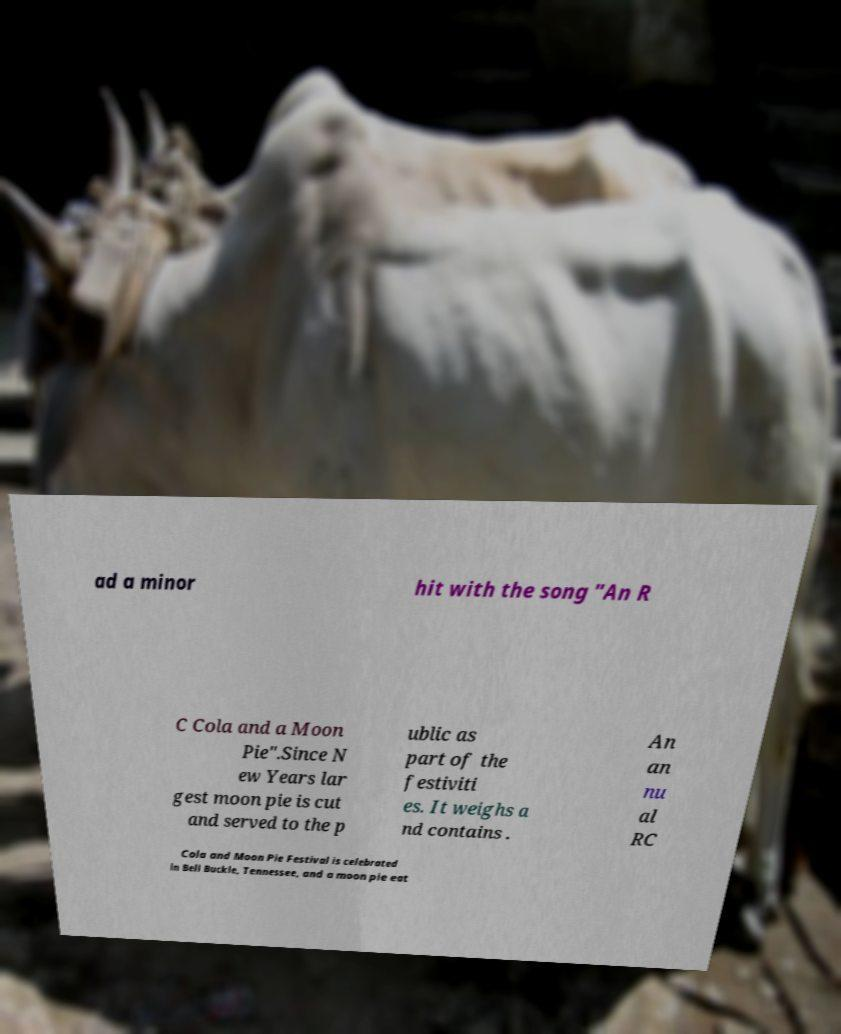Could you extract and type out the text from this image? ad a minor hit with the song "An R C Cola and a Moon Pie".Since N ew Years lar gest moon pie is cut and served to the p ublic as part of the festiviti es. It weighs a nd contains . An an nu al RC Cola and Moon Pie Festival is celebrated in Bell Buckle, Tennessee, and a moon pie eat 